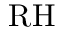<formula> <loc_0><loc_0><loc_500><loc_500>R H</formula> 